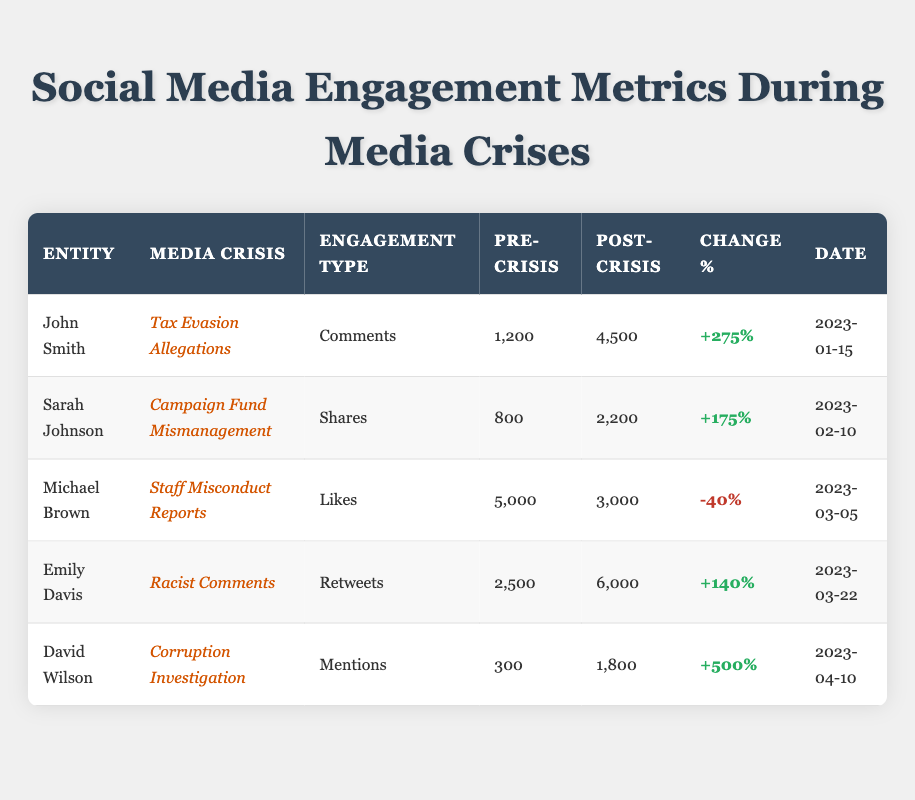What was the engagement change percentage for John Smith during the Tax Evasion Allegations crisis? According to the table, John Smith had an engagement change percentage of +275% during the Tax Evasion Allegations crisis.
Answer: +275% Which crisis had the highest post-crisis engagement in terms of comments? The crisis that had the highest post-crisis engagement in terms of comments was John Smith's Tax Evasion Allegations, with a total of 4,500 comments post-crisis.
Answer: 4,500 comments Did Michael Brown experience an increase in likes after the Staff Misconduct Reports crisis? No, Michael Brown experienced a decrease in likes after the Staff Misconduct Reports crisis, as indicated by the engagement change percentage of -40%.
Answer: No What is the average engagement change percentage for the entities in the table? To find the average engagement change percentage, we sum the engagement change percentages: 275% + 175% - 40% + 140% + 500% = 1,050%. There are 5 entries, so the average is 1,050% / 5 = 210%.
Answer: 210% Which entity saw the most significant increase in mentions post-crisis? David Wilson saw the most significant increase in mentions post-crisis, with an increase of 1,500 mentions (from 300 to 1,800).
Answer: David Wilson Which engagement type showed a negative trend for Michael Brown? The engagement type that showed a negative trend for Michael Brown was Likes, which decreased from 5,000 pre-crisis to 3,000 post-crisis.
Answer: Likes How many total retweets did Emily Davis receive post-crisis? Emily Davis received 6,000 retweets post-crisis, as stated in the table.
Answer: 6,000 retweets Which crisis had the lowest pre-crisis engagement in shares? The crisis with the lowest pre-crisis engagement in shares was Sarah Johnson's Campaign Fund Mismanagement, with only 800 shares before the crisis began.
Answer: 800 shares 